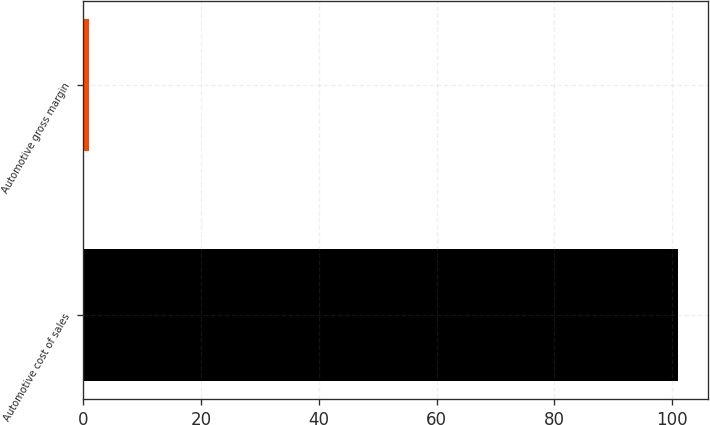<chart> <loc_0><loc_0><loc_500><loc_500><bar_chart><fcel>Automotive cost of sales<fcel>Automotive gross margin<nl><fcel>101<fcel>1<nl></chart> 